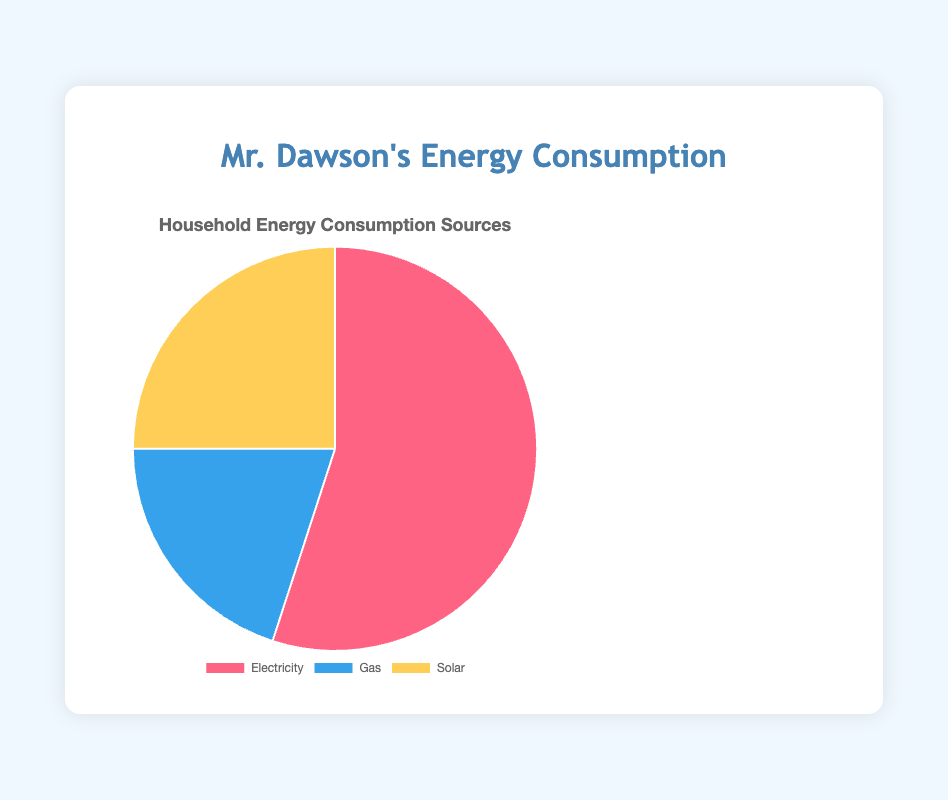What percentage of Mr. Dawson’s energy consumption is from Gas? In the pie chart, the slice for Gas indicates 20%. Therefore, 20% of Mr. Dawson's energy consumption comes from Gas.
Answer: 20% Which energy source does Mr. Dawson use the most? According to the pie chart, Mr. Dawson uses Electricity the most, which takes up 55% of the total.
Answer: Electricity Does Mr. Dawson use more Solar energy or Gas? The pie chart shows that Solar energy accounts for 25%, and Gas accounts for 20%. Since 25% > 20%, Mr. Dawson uses more Solar energy.
Answer: Solar What is the combined percentage of Solar and Gas consumption for Mr. Dawson? According to the pie chart, Solar accounts for 25% and Gas for 20%. Adding these gives 25% + 20% = 45%.
Answer: 45% How much higher is the percentage of Electricity usage compared to Gas usage for Mr. Dawson? The pie chart shows Electricity at 55% and Gas at 20%. The difference is 55% - 20% = 35%.
Answer: 35% Which energy source has the smallest share in Mr. Dawson's consumption? According to the pie chart, Gas has the smallest share at 20%.
Answer: Gas Is the percentage of Solar energy consumption greater than that of Gas if combined with half of the Electricity consumption in Mr. Dawson's household? Mr. Dawson's Electricity consumption is 55%. Half of this is 27.5%. Combining this with Solar (25%) gives 27.5% + 25% = 52.5%. Comparing 52.5% to Gas (20%) indicates that the combined value is much greater.
Answer: Yes How many times more does Mr. Dawson use Electricity compared to Gas? The pie chart shows Electricity at 55% and Gas at 20%. Dividing these gives 55% / 20% = 2.75 times.
Answer: 2.75 times What is the average percentage of all three energy sources in Mr. Dawson's consumption? The pie chart shows Electricity at 55%, Gas at 20%, and Solar at 25%. Adding these gives 55% + 20% + 25% = 100%. Dividing by 3, the average is 100% / 3 ≈ 33.33%.
Answer: 33.33% 